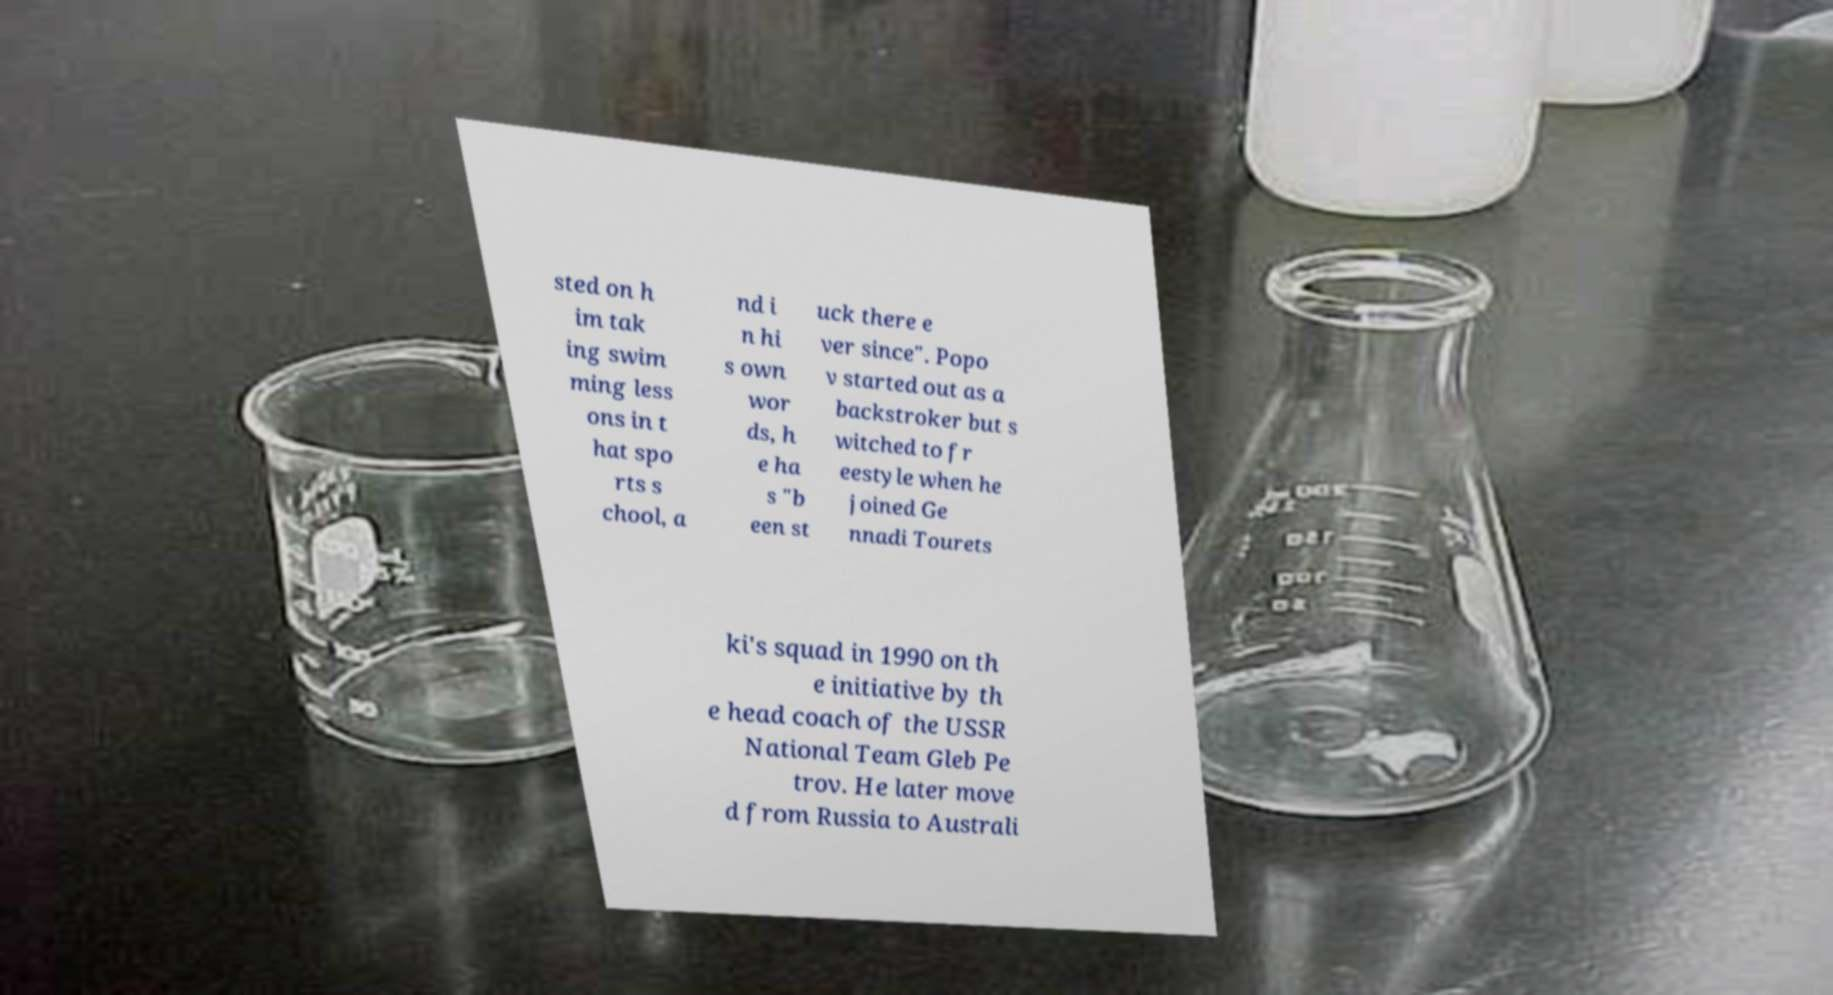Can you accurately transcribe the text from the provided image for me? sted on h im tak ing swim ming less ons in t hat spo rts s chool, a nd i n hi s own wor ds, h e ha s "b een st uck there e ver since". Popo v started out as a backstroker but s witched to fr eestyle when he joined Ge nnadi Tourets ki's squad in 1990 on th e initiative by th e head coach of the USSR National Team Gleb Pe trov. He later move d from Russia to Australi 